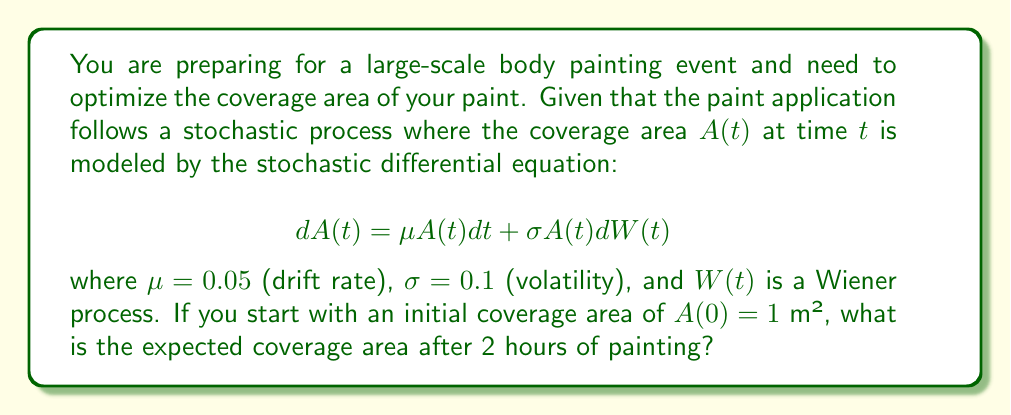Can you solve this math problem? To solve this problem, we'll use Itô's lemma and the properties of the geometric Brownian motion:

1) The stochastic differential equation given describes a geometric Brownian motion.

2) For a geometric Brownian motion, the expected value at time $t$ is given by:

   $$E[A(t)] = A(0)e^{\mu t}$$

3) In this case:
   - $A(0) = 1$ m² (initial coverage area)
   - $\mu = 0.05$ (drift rate)
   - $t = 2$ hours

4) Substituting these values into the formula:

   $$E[A(2)] = 1 \cdot e^{0.05 \cdot 2}$$

5) Calculating:
   $$E[A(2)] = e^{0.1} \approx 1.1052$$

Therefore, the expected coverage area after 2 hours of painting is approximately 1.1052 m².
Answer: 1.1052 m² 